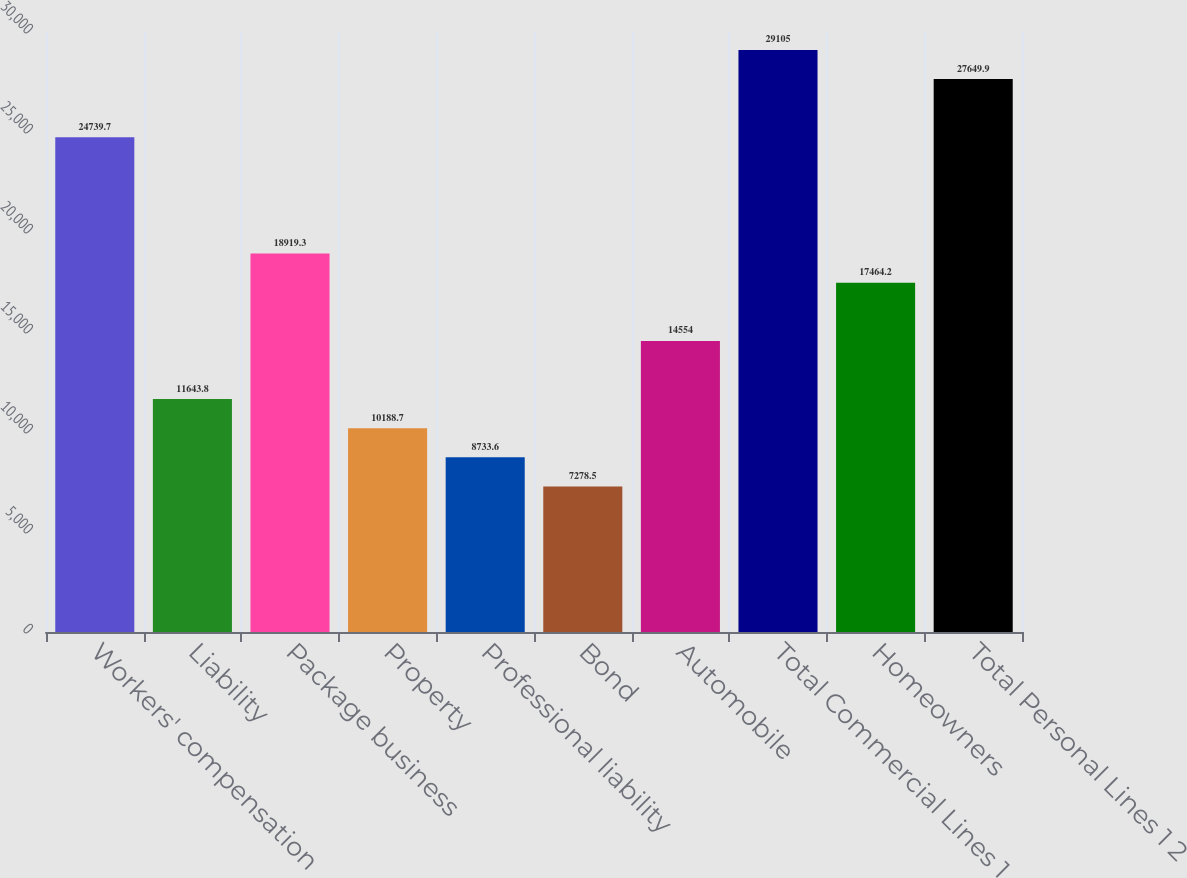<chart> <loc_0><loc_0><loc_500><loc_500><bar_chart><fcel>Workers' compensation<fcel>Liability<fcel>Package business<fcel>Property<fcel>Professional liability<fcel>Bond<fcel>Automobile<fcel>Total Commercial Lines 1<fcel>Homeowners<fcel>Total Personal Lines 1 2<nl><fcel>24739.7<fcel>11643.8<fcel>18919.3<fcel>10188.7<fcel>8733.6<fcel>7278.5<fcel>14554<fcel>29105<fcel>17464.2<fcel>27649.9<nl></chart> 